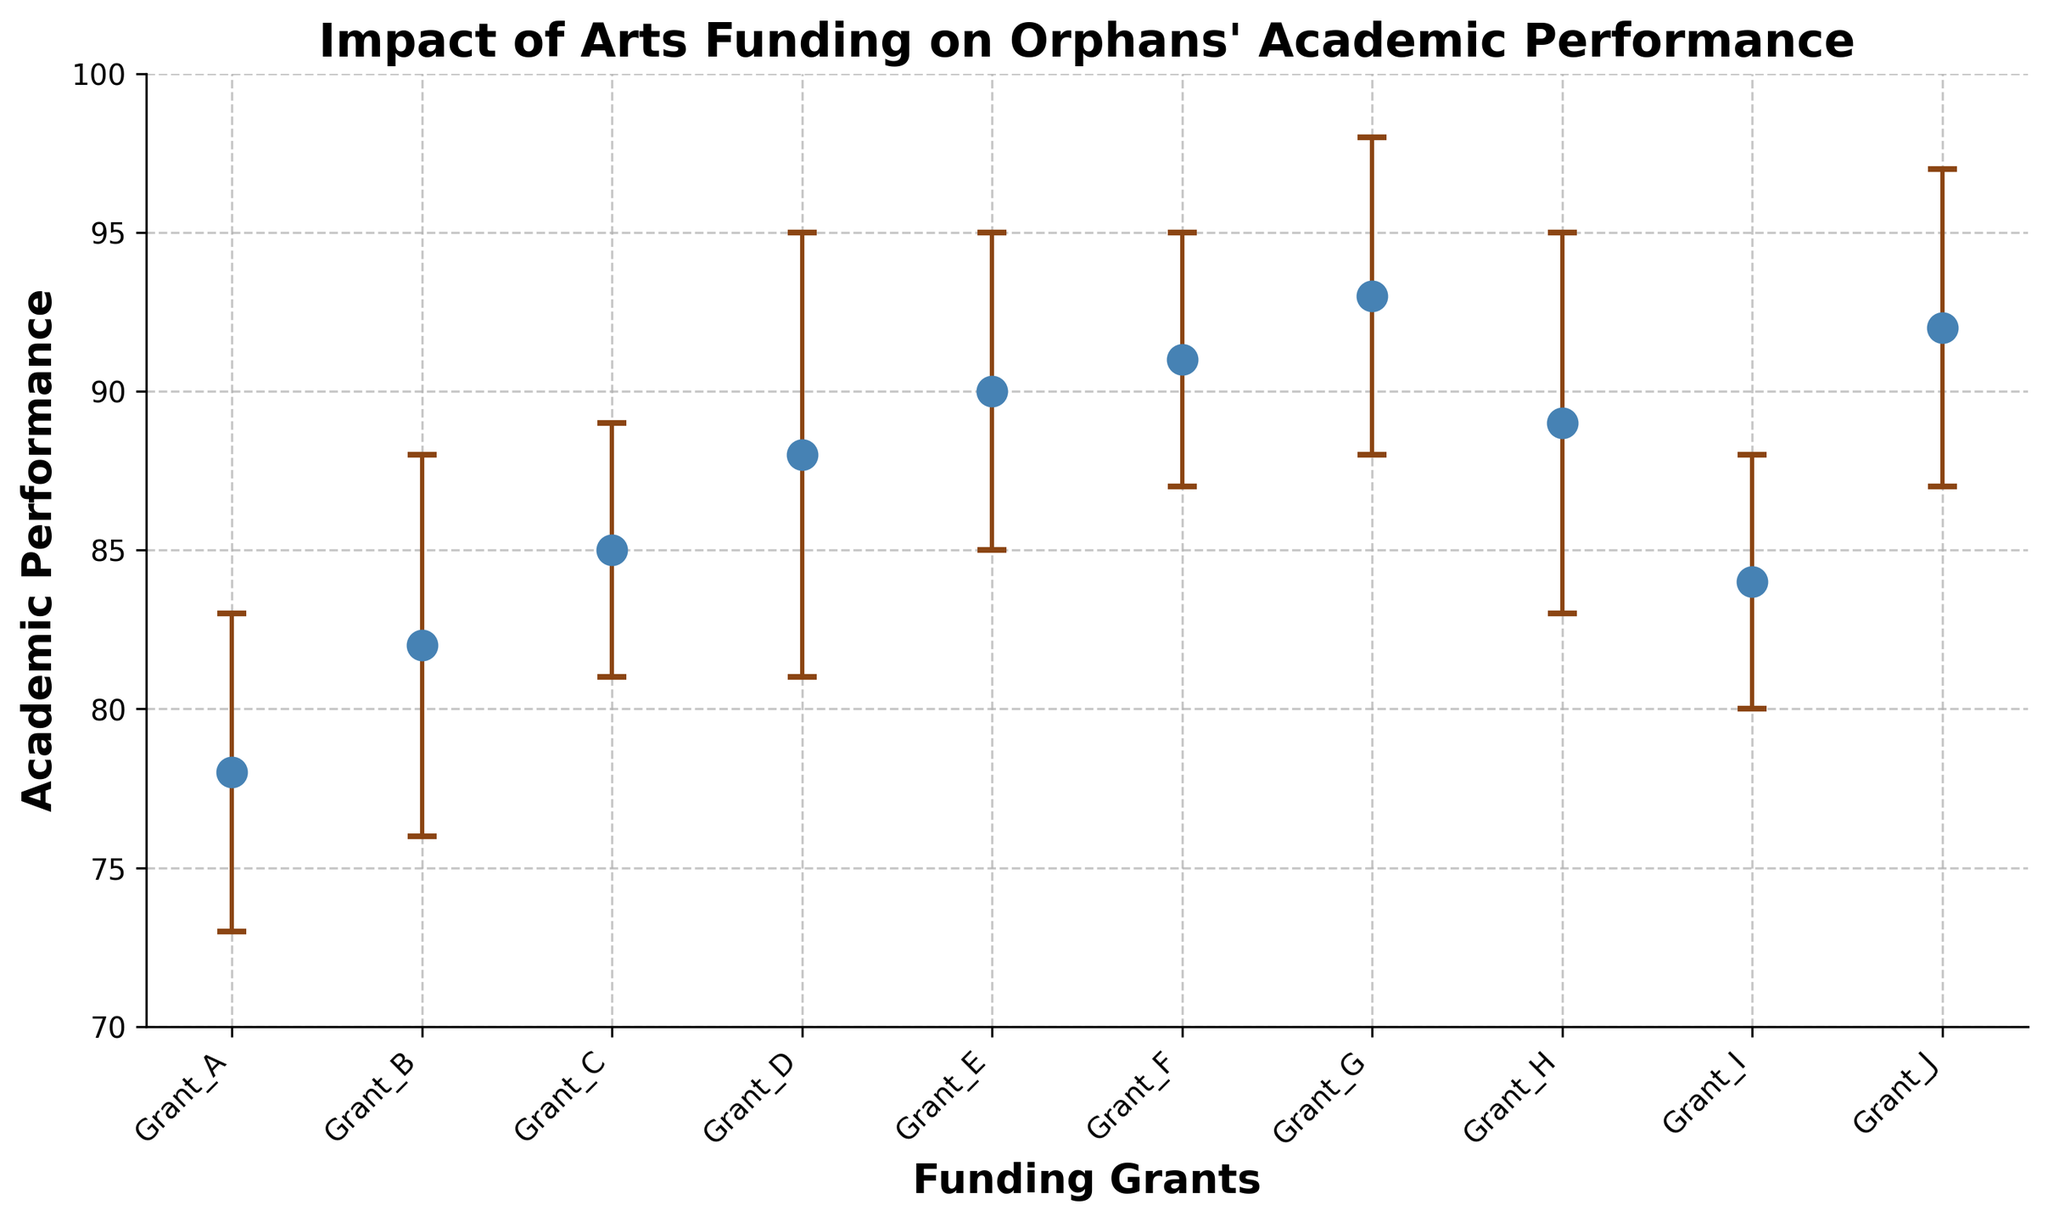What's the title of the figure? The title of the figure is displayed at the top of the chart.
Answer: Impact of Arts Funding on Orphans' Academic Performance What are the labels of the x-axis and y-axis? The x-axis label is found below the horizontal axis, and the y-axis label is found beside the vertical axis.
Answer: Funding Grants, Academic Performance How many funding grants are plotted in the chart? Count the total number of data points or markers on the scatter plot.
Answer: 10 Which funding grant has the highest academic performance? Identify the data point with the highest value on the y-axis for academic performance.
Answer: Grant G What is the academic performance for Grant A? Find the corresponding data point on the chart for Grant A and read off the y-axis value.
Answer: 78 What is the average academic performance across all funding grants? Sum all the academic performance values and divide by the number of funding grants. Calculation: (78 + 82 + 85 + 88 + 90 + 91 + 93 + 89 + 84 + 92)/10 = 87.2
Answer: 87.2 Which grants have an academic performance of 90 or above? Look for data points with values of 90 or higher on the y-axis and list the corresponding funding grants.
Answer: Grant E, Grant F, Grant G, Grant J What is the error range for Grant D's academic performance? Find the error value for Grant D and provide the upper and lower range based on the y-axis value of Grant D. Academic Performance = 88, Error = 7, Upper Range = 88 + 7 = 95, Lower Range = 88 - 7 = 81
Answer: 81 to 95 How does the academic performance for Grant H compare to Grant C? Compare the y-axis values for Grant H and Grant C. Grant H = 89, Grant C = 85, so Grant H has a higher academic performance than Grant C.
Answer: Grant H is higher Which funding grant has the largest error bar, and what is its value? Look for the data point with the longest vertical error bar and identify the corresponding funding grant.
Answer: Grant D, 7 